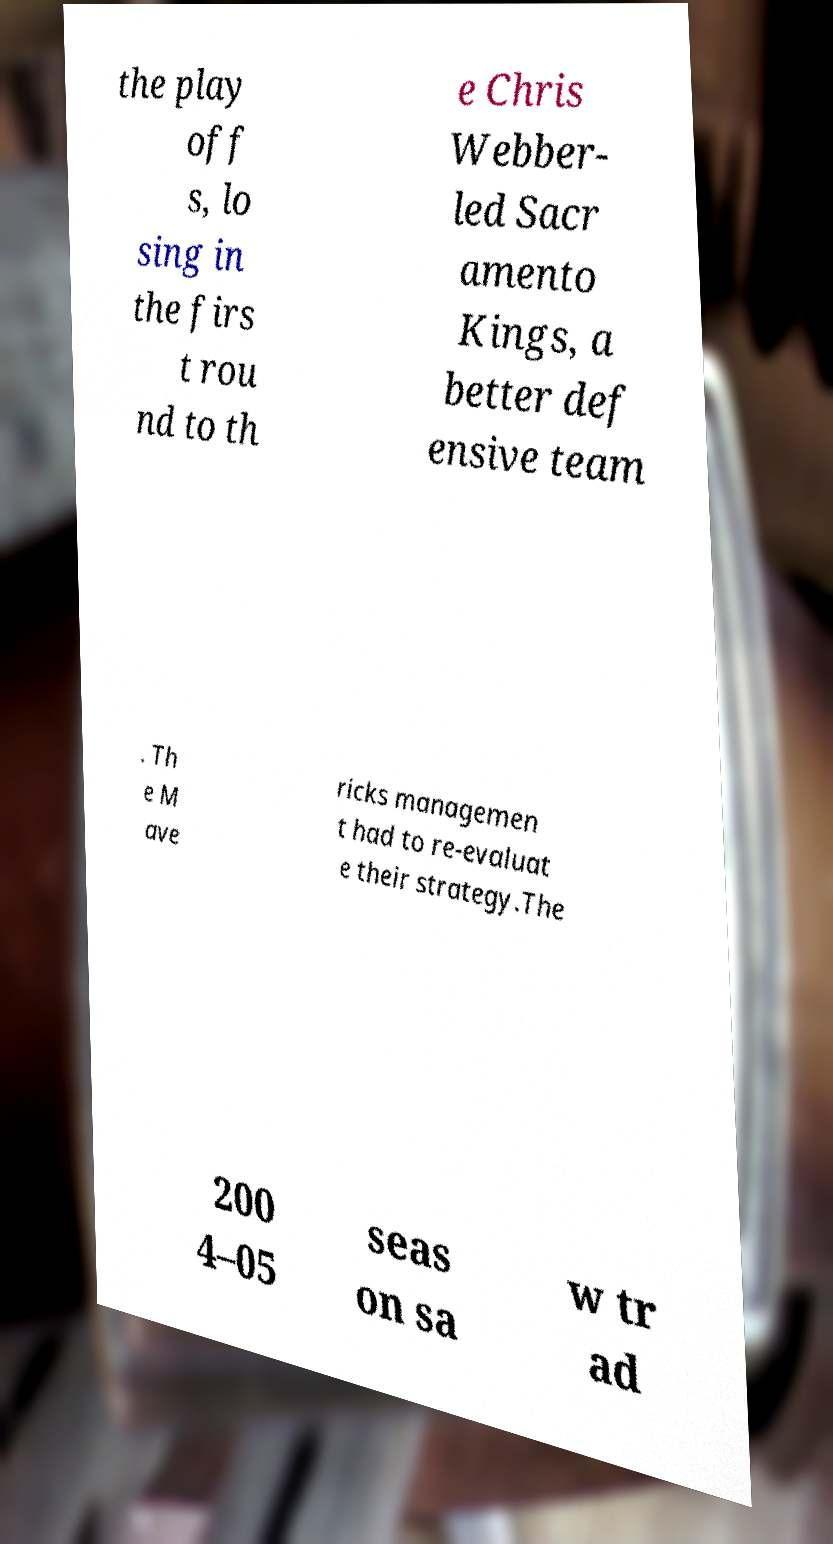Could you assist in decoding the text presented in this image and type it out clearly? the play off s, lo sing in the firs t rou nd to th e Chris Webber- led Sacr amento Kings, a better def ensive team . Th e M ave ricks managemen t had to re-evaluat e their strategy.The 200 4–05 seas on sa w tr ad 